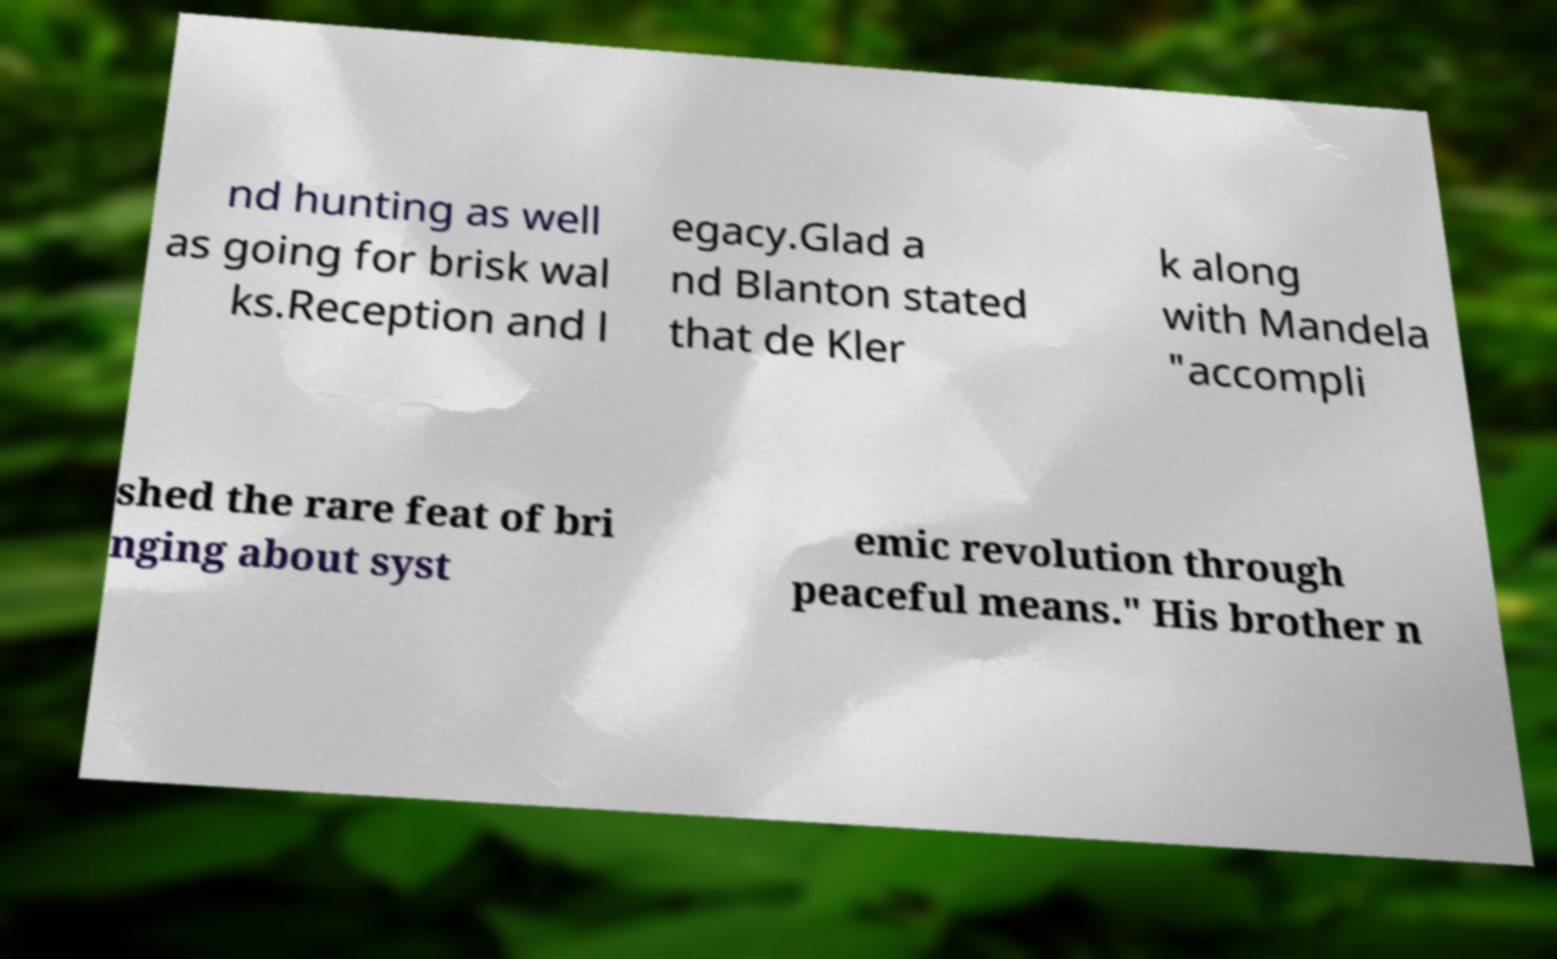Can you read and provide the text displayed in the image?This photo seems to have some interesting text. Can you extract and type it out for me? nd hunting as well as going for brisk wal ks.Reception and l egacy.Glad a nd Blanton stated that de Kler k along with Mandela "accompli shed the rare feat of bri nging about syst emic revolution through peaceful means." His brother n 